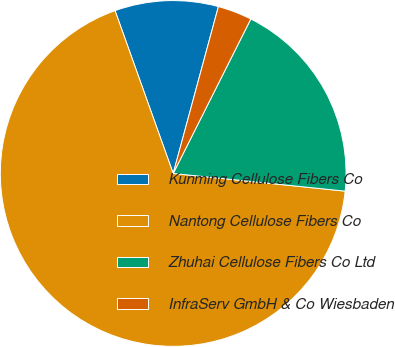<chart> <loc_0><loc_0><loc_500><loc_500><pie_chart><fcel>Kunming Cellulose Fibers Co<fcel>Nantong Cellulose Fibers Co<fcel>Zhuhai Cellulose Fibers Co Ltd<fcel>InfraServ GmbH & Co Wiesbaden<nl><fcel>9.67%<fcel>67.91%<fcel>19.22%<fcel>3.2%<nl></chart> 